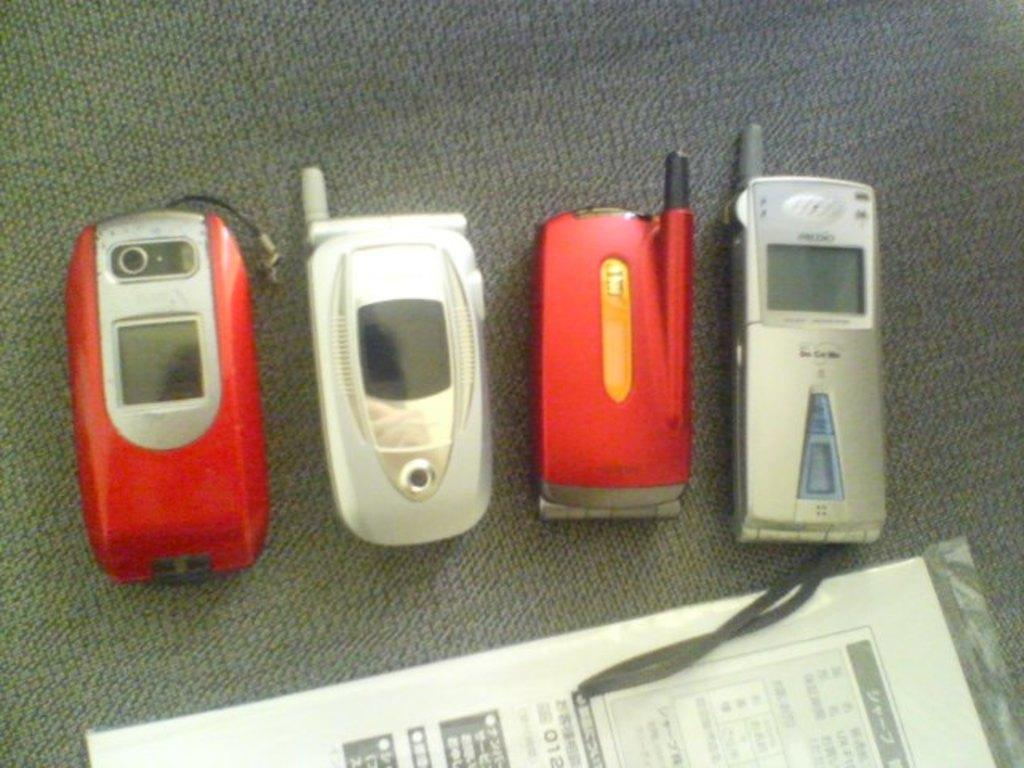What is the color of the surface in the image? The surface in the image is grey. How many mobiles are on the surface? There are four mobiles on the surface. What colors do the mobiles have? The mobiles have different colors: grey, red, and black. Is there any paper visible in the image? Yes, there is a paper in a cover in the image. What type of fruit is hidden under the grey mobile in the image? There is no fruit present in the image, and no mobile is hiding anything. 